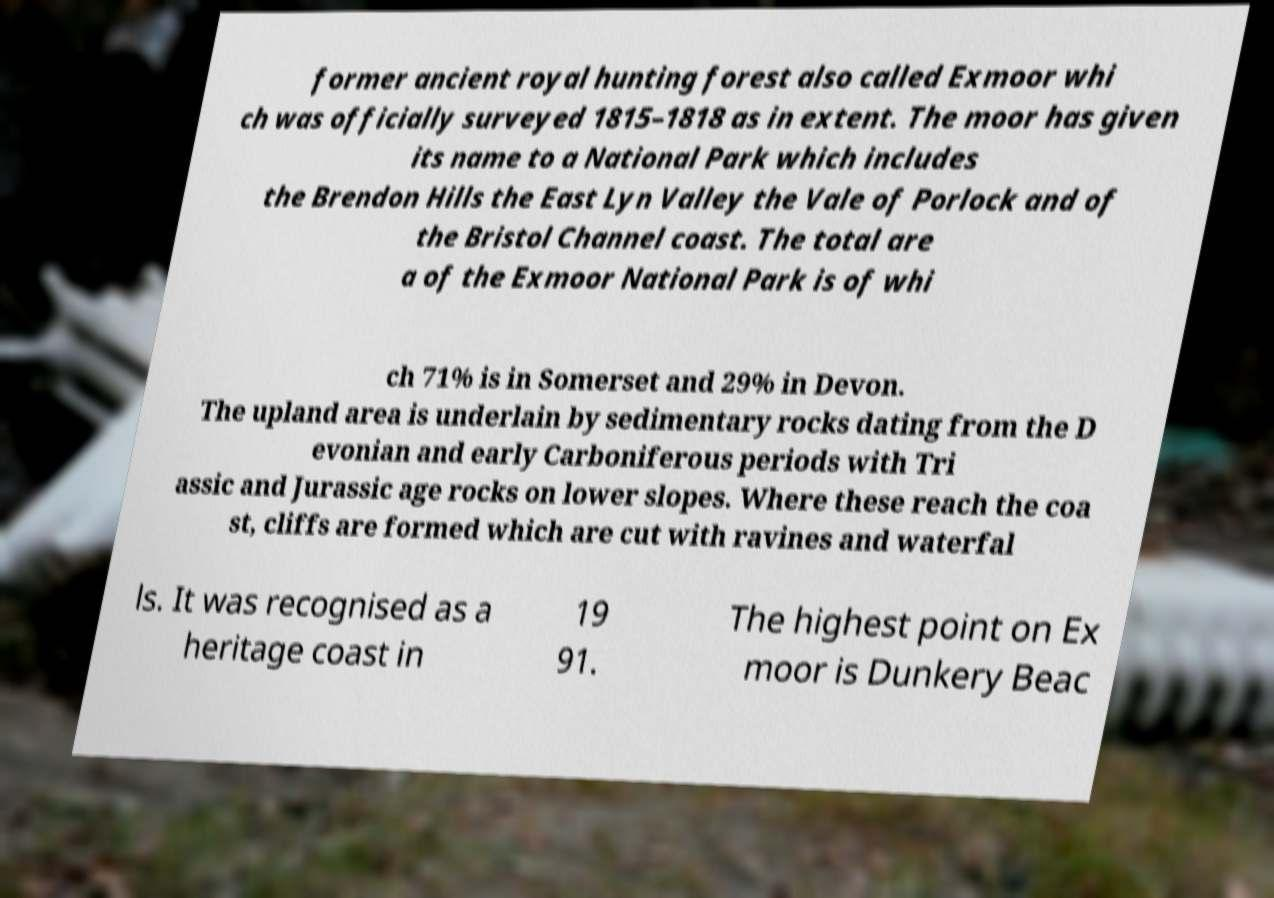For documentation purposes, I need the text within this image transcribed. Could you provide that? former ancient royal hunting forest also called Exmoor whi ch was officially surveyed 1815–1818 as in extent. The moor has given its name to a National Park which includes the Brendon Hills the East Lyn Valley the Vale of Porlock and of the Bristol Channel coast. The total are a of the Exmoor National Park is of whi ch 71% is in Somerset and 29% in Devon. The upland area is underlain by sedimentary rocks dating from the D evonian and early Carboniferous periods with Tri assic and Jurassic age rocks on lower slopes. Where these reach the coa st, cliffs are formed which are cut with ravines and waterfal ls. It was recognised as a heritage coast in 19 91. The highest point on Ex moor is Dunkery Beac 